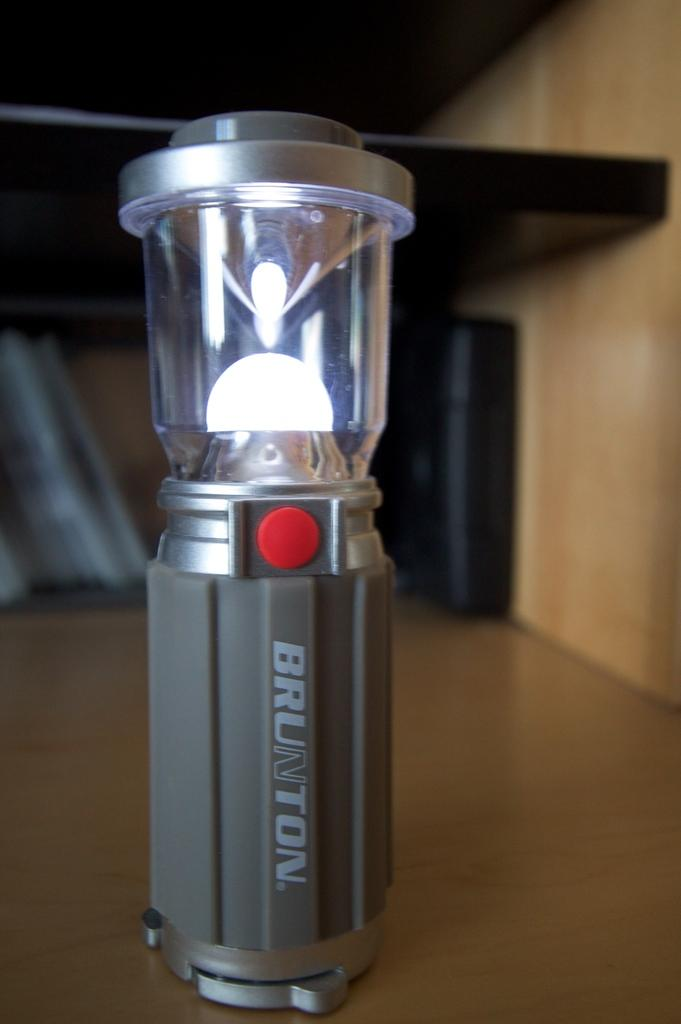<image>
Offer a succinct explanation of the picture presented. A lantern bearing the name Brunton and with a red button on its front sits on a table. 